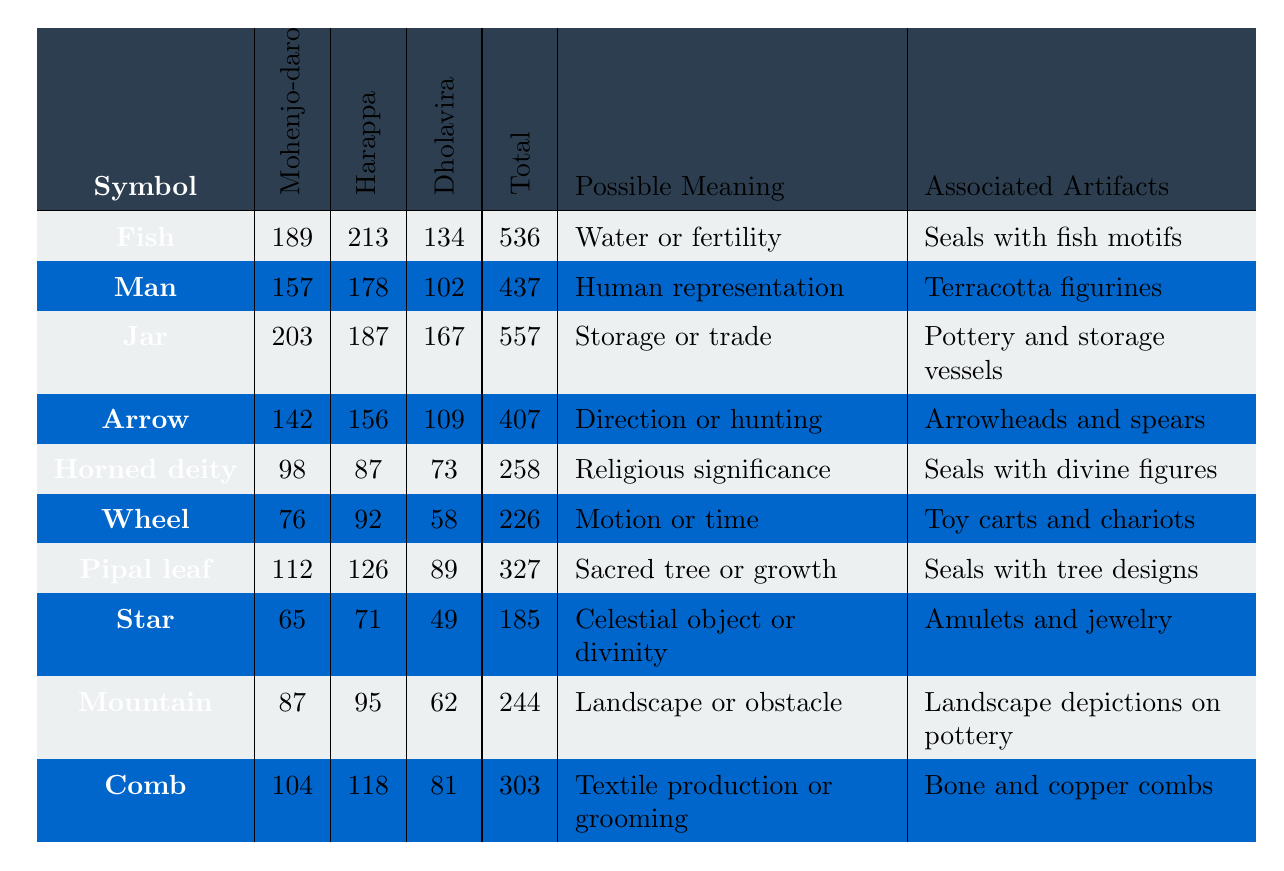What is the most frequently occurring symbol in Mohenjo-daro? The table shows the frequency of each symbol in Mohenjo-daro. The highest frequency is 203 for the symbol "Jar."
Answer: Jar What is the total frequency of the "Fish" symbol across all three sites? Adding the frequencies for "Fish": 189 (Mohenjo-daro) + 213 (Harappa) + 134 (Dholavira) = 536.
Answer: 536 Which symbol has the highest total occurrence across all sites? The total occurrences are: Fish (536), Man (437), Jar (557), Arrow (407), Horned deity (258), Wheel (226), Pipal leaf (327), Star (185), Mountain (244), and Comb (303). "Jar" has the highest total of 557.
Answer: Jar Does the symbol "Horned deity" have a possible meaning related to hunting? The possible meaning for "Horned deity" listed in the table is "Religious significance," which does not relate to hunting.
Answer: No What is the average frequency of the "Wheel" symbol across the three sites? The frequencies for "Wheel" are 76 (Mohenjo-daro), 92 (Harappa), and 58 (Dholavira). Average = (76 + 92 + 58) / 3 = 75.33.
Answer: 75.33 How many more occurrences does the "Man" symbol have in Harappa compared to Dholavira? The frequencies are 178 (Harappa) and 102 (Dholavira). The difference is 178 - 102 = 76.
Answer: 76 Is there any symbol that has a frequency lower than 100 in any of the sites? Looking at the frequencies, "Wheel" and "Horned deity" have counts below 100 in Mohenjo-daro and Harappa, respectively. Therefore, the answer is yes.
Answer: Yes What percentage of the total occurrences for the "Star" symbol comes from Harappa? The frequencies are 65 (Mohenjo-daro), 71 (Harappa), and 49 (Dholavira). Total = 185. The percentage from Harappa is (71 / 185) x 100 = 38.38%.
Answer: 38.38% Which symbol has the least frequency in Dholavira? The frequencies for Dholavira are: 134 (Fish), 102 (Man), 167 (Jar), 109 (Arrow), 73 (Horned deity), 58 (Wheel), 89 (Pipal leaf), 49 (Star), 62 (Mountain), and 81 (Comb). The least frequency is 49 for the "Star".
Answer: Star How does the frequency of the "Comb" symbol in Harappa compare to its frequency in Mohenjo-daro? The frequency in Harappa is 118 and in Mohenjo-daro is 104. Thus, it is higher in Harappa by 14.
Answer: 14 